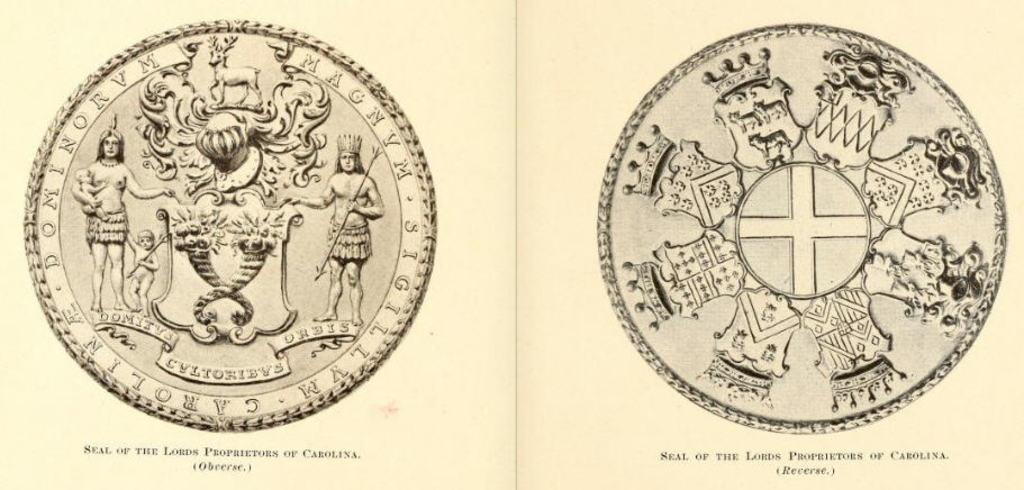<image>
Create a compact narrative representing the image presented. A coin display with the words Seal of the Lords Proprietors of Carolina written on it. 